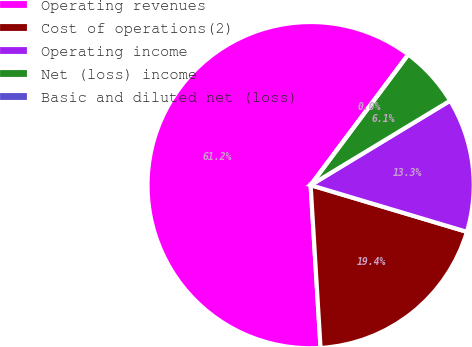<chart> <loc_0><loc_0><loc_500><loc_500><pie_chart><fcel>Operating revenues<fcel>Cost of operations(2)<fcel>Operating income<fcel>Net (loss) income<fcel>Basic and diluted net (loss)<nl><fcel>61.19%<fcel>19.41%<fcel>13.29%<fcel>6.12%<fcel>0.0%<nl></chart> 